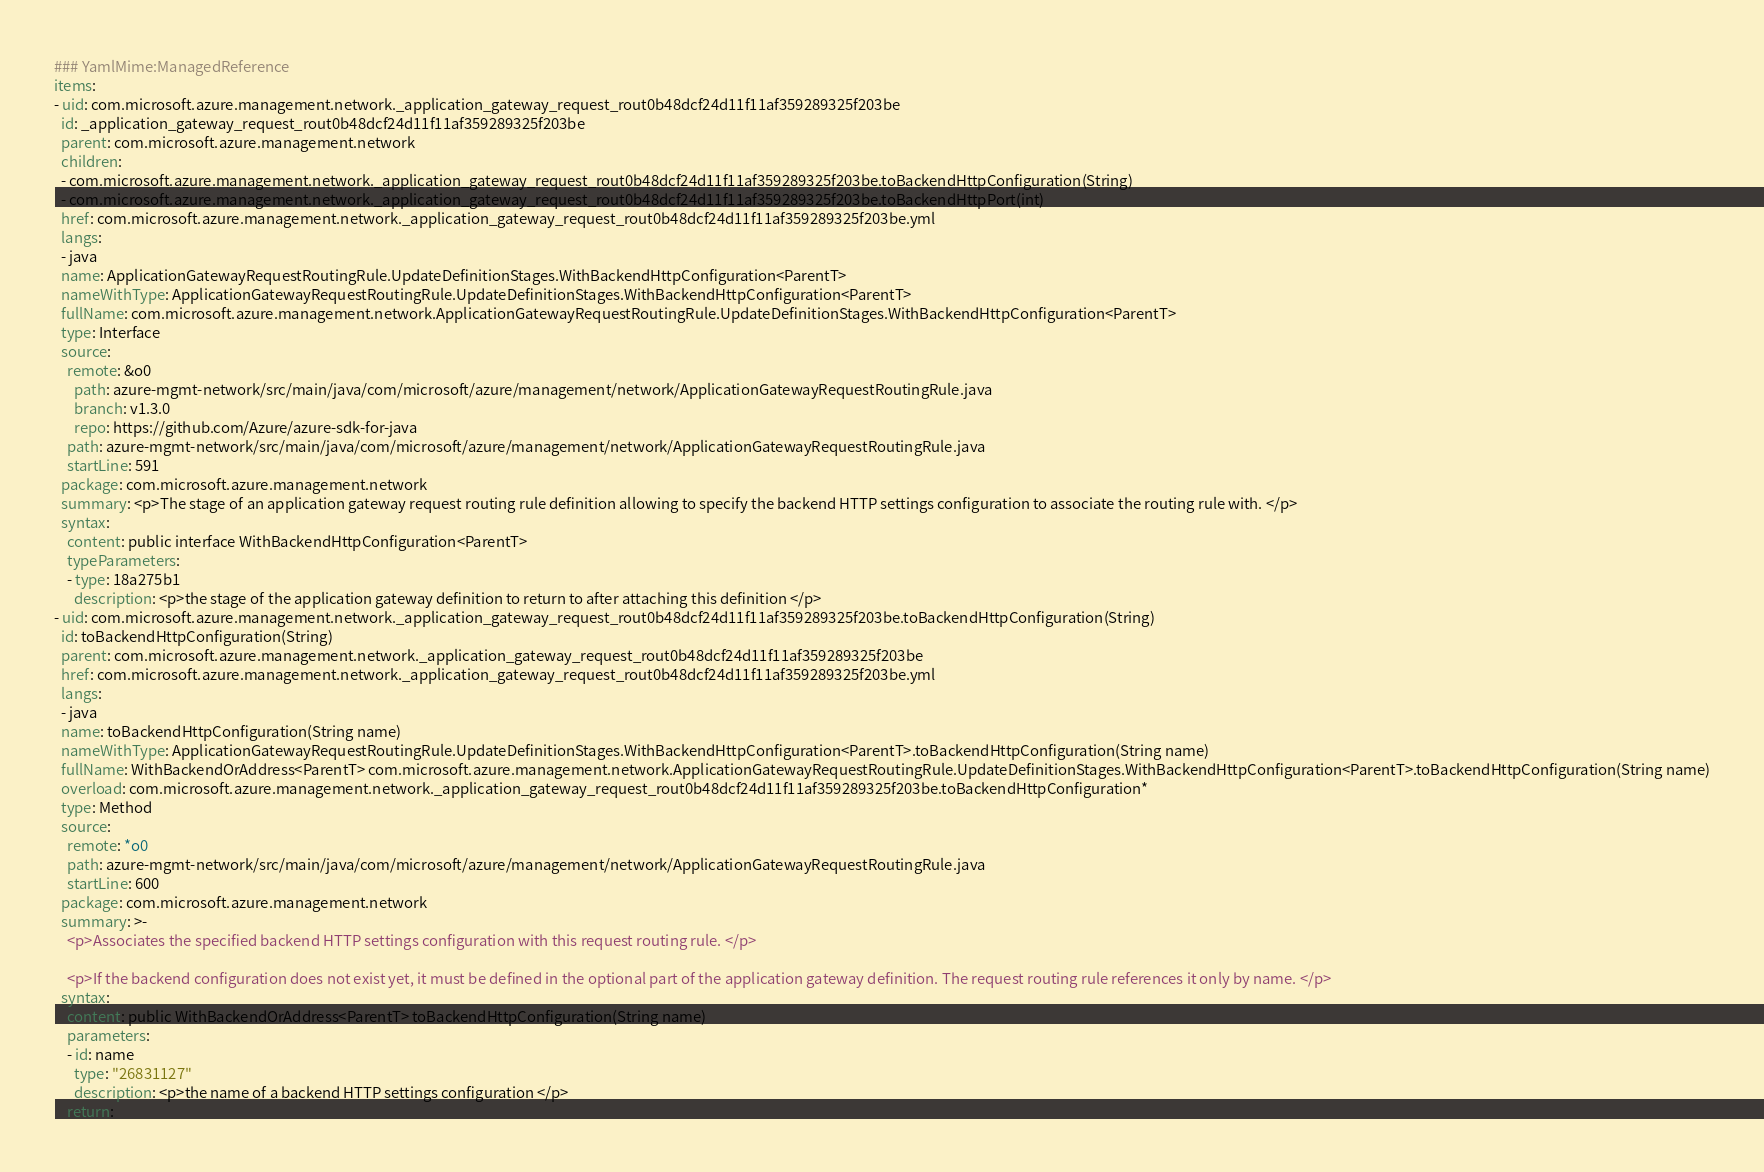<code> <loc_0><loc_0><loc_500><loc_500><_YAML_>### YamlMime:ManagedReference
items:
- uid: com.microsoft.azure.management.network._application_gateway_request_rout0b48dcf24d11f11af359289325f203be
  id: _application_gateway_request_rout0b48dcf24d11f11af359289325f203be
  parent: com.microsoft.azure.management.network
  children:
  - com.microsoft.azure.management.network._application_gateway_request_rout0b48dcf24d11f11af359289325f203be.toBackendHttpConfiguration(String)
  - com.microsoft.azure.management.network._application_gateway_request_rout0b48dcf24d11f11af359289325f203be.toBackendHttpPort(int)
  href: com.microsoft.azure.management.network._application_gateway_request_rout0b48dcf24d11f11af359289325f203be.yml
  langs:
  - java
  name: ApplicationGatewayRequestRoutingRule.UpdateDefinitionStages.WithBackendHttpConfiguration<ParentT>
  nameWithType: ApplicationGatewayRequestRoutingRule.UpdateDefinitionStages.WithBackendHttpConfiguration<ParentT>
  fullName: com.microsoft.azure.management.network.ApplicationGatewayRequestRoutingRule.UpdateDefinitionStages.WithBackendHttpConfiguration<ParentT>
  type: Interface
  source:
    remote: &o0
      path: azure-mgmt-network/src/main/java/com/microsoft/azure/management/network/ApplicationGatewayRequestRoutingRule.java
      branch: v1.3.0
      repo: https://github.com/Azure/azure-sdk-for-java
    path: azure-mgmt-network/src/main/java/com/microsoft/azure/management/network/ApplicationGatewayRequestRoutingRule.java
    startLine: 591
  package: com.microsoft.azure.management.network
  summary: <p>The stage of an application gateway request routing rule definition allowing to specify the backend HTTP settings configuration to associate the routing rule with. </p>
  syntax:
    content: public interface WithBackendHttpConfiguration<ParentT>
    typeParameters:
    - type: 18a275b1
      description: <p>the stage of the application gateway definition to return to after attaching this definition </p>
- uid: com.microsoft.azure.management.network._application_gateway_request_rout0b48dcf24d11f11af359289325f203be.toBackendHttpConfiguration(String)
  id: toBackendHttpConfiguration(String)
  parent: com.microsoft.azure.management.network._application_gateway_request_rout0b48dcf24d11f11af359289325f203be
  href: com.microsoft.azure.management.network._application_gateway_request_rout0b48dcf24d11f11af359289325f203be.yml
  langs:
  - java
  name: toBackendHttpConfiguration(String name)
  nameWithType: ApplicationGatewayRequestRoutingRule.UpdateDefinitionStages.WithBackendHttpConfiguration<ParentT>.toBackendHttpConfiguration(String name)
  fullName: WithBackendOrAddress<ParentT> com.microsoft.azure.management.network.ApplicationGatewayRequestRoutingRule.UpdateDefinitionStages.WithBackendHttpConfiguration<ParentT>.toBackendHttpConfiguration(String name)
  overload: com.microsoft.azure.management.network._application_gateway_request_rout0b48dcf24d11f11af359289325f203be.toBackendHttpConfiguration*
  type: Method
  source:
    remote: *o0
    path: azure-mgmt-network/src/main/java/com/microsoft/azure/management/network/ApplicationGatewayRequestRoutingRule.java
    startLine: 600
  package: com.microsoft.azure.management.network
  summary: >-
    <p>Associates the specified backend HTTP settings configuration with this request routing rule. </p>

    <p>If the backend configuration does not exist yet, it must be defined in the optional part of the application gateway definition. The request routing rule references it only by name. </p>
  syntax:
    content: public WithBackendOrAddress<ParentT> toBackendHttpConfiguration(String name)
    parameters:
    - id: name
      type: "26831127"
      description: <p>the name of a backend HTTP settings configuration </p>
    return:</code> 